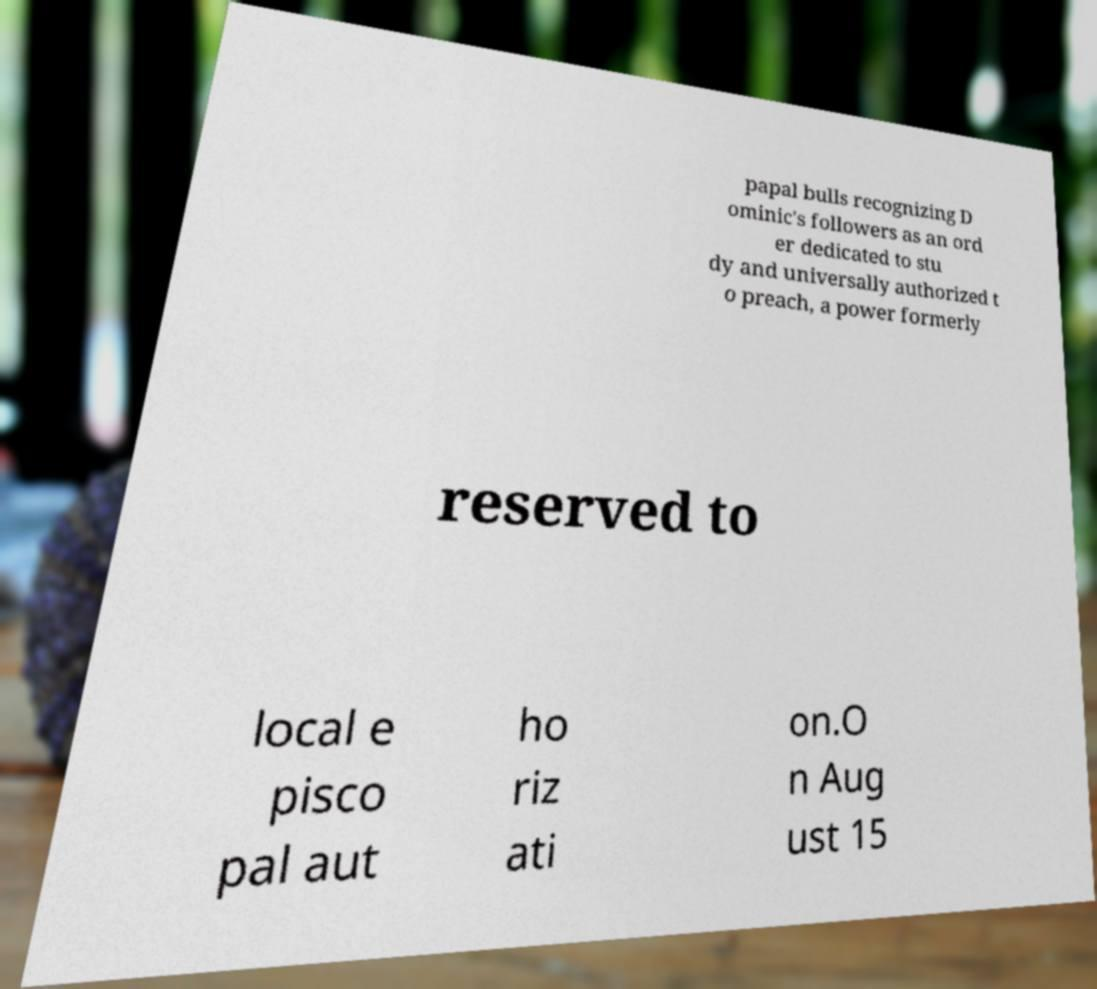Can you read and provide the text displayed in the image?This photo seems to have some interesting text. Can you extract and type it out for me? papal bulls recognizing D ominic's followers as an ord er dedicated to stu dy and universally authorized t o preach, a power formerly reserved to local e pisco pal aut ho riz ati on.O n Aug ust 15 